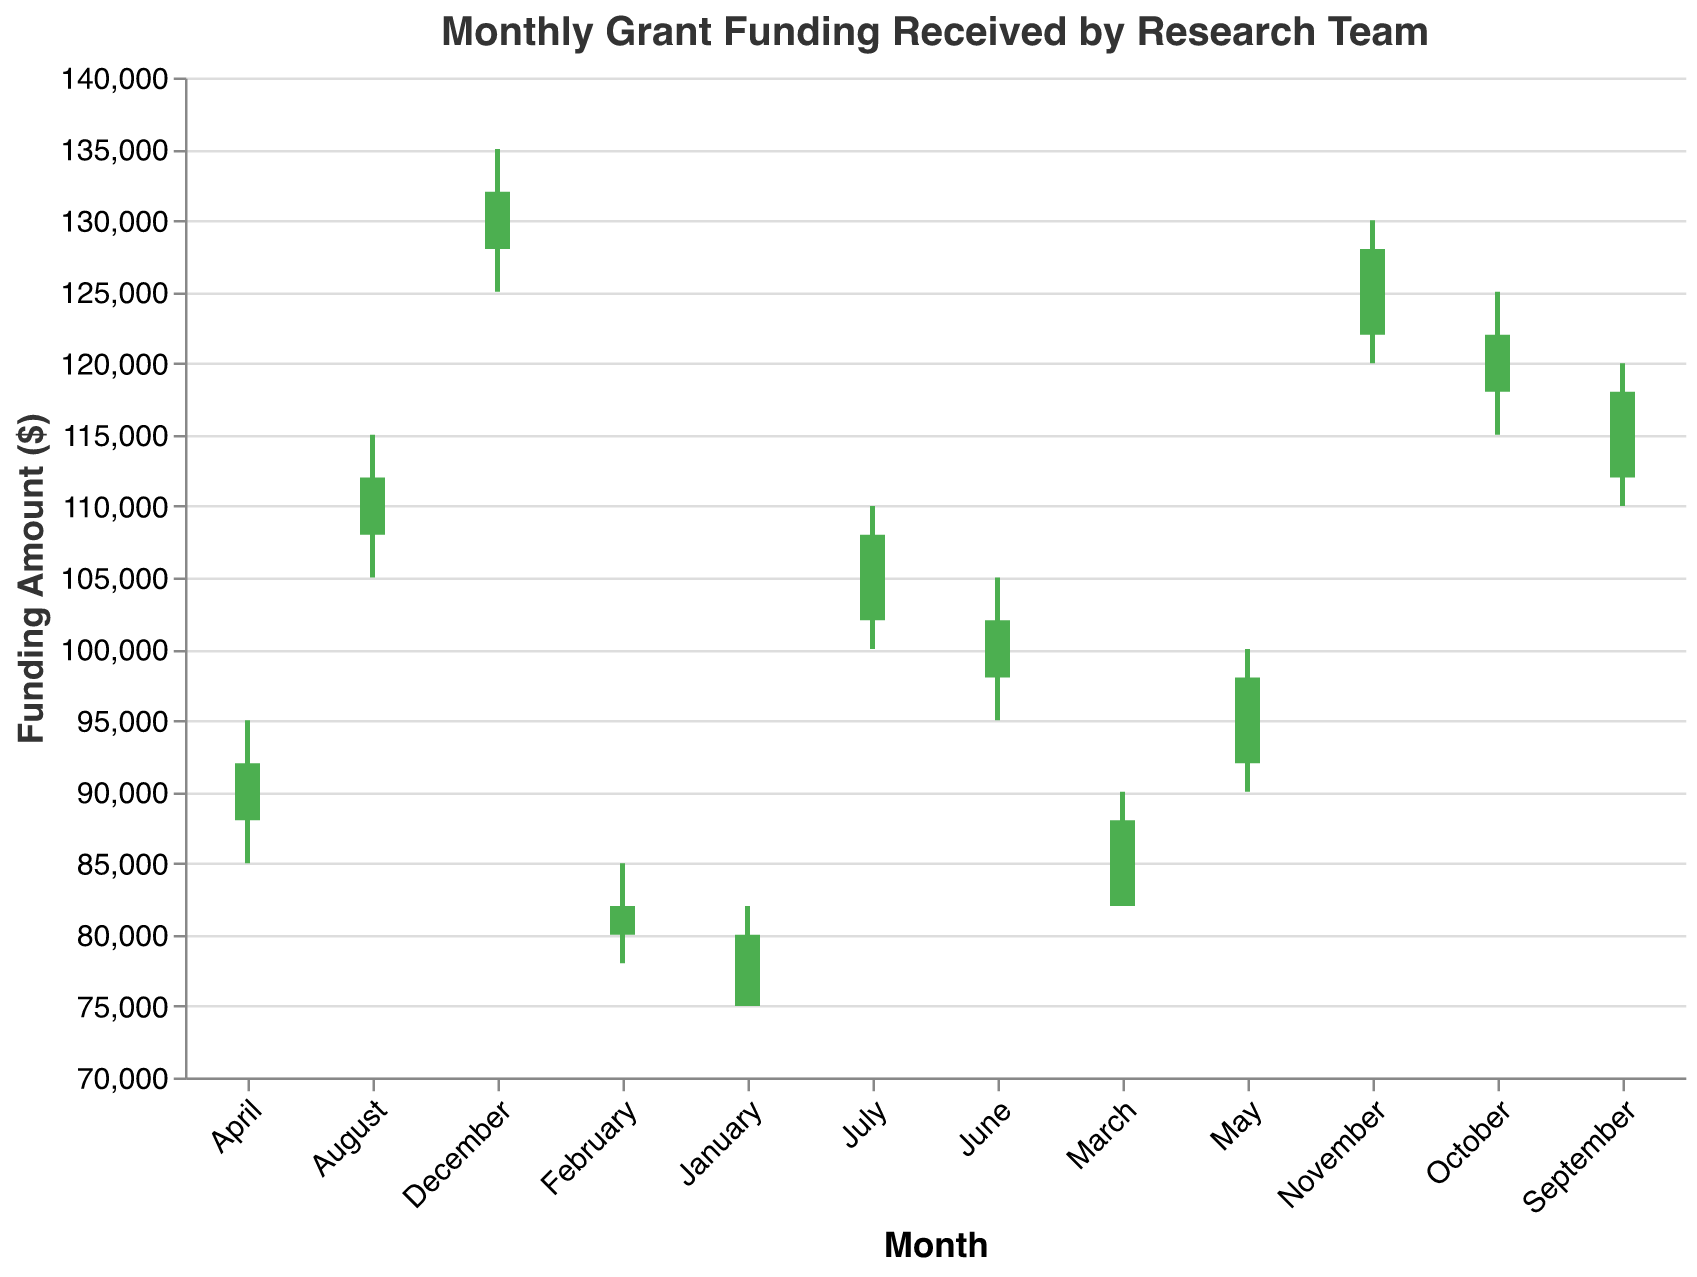what is the title of the figure? The title is displayed at the top of the figure, indicating its main subject.
Answer: Monthly Grant Funding Received by Research Team What is the final funding amount in June? The final funding amount for June can be found at the endpoint of the corresponding bar in June.
Answer: 102000 During which month did the research team receive an initial funding amount of 75000? The initial funding amount for each month is marked at the beginning of the bar along the horizontal axis, with 75000 being the initial amount for January.
Answer: January Which month had the highest peak funding? The peak funding is the maximum funding amount in the month, represented by the top point on the vertical line. The highest peak on the chart belongs to December (135000).
Answer: December What is the difference between the peak and the lowest funding amount in September? Subtract the lowest funding amount for September from the peak funding amount. Peak (120000) - Lowest (110000) = 10000.
Answer: 10000 Which months had a final funding amount greater than the initial funding amount? Look for bars where the final point is above the initial point on the vertical axis. The months are: January, February, March, April, May, June, July, August, September, October, November, December.
Answer: All months had a final funding amount greater than the initial What was the average peak funding amount over the first quarter (January, February, March)? Add the peak amounts for January, February, and March and divide by the number of months (3). (82000 + 85000 + 90000) / 3 = 85667.
Answer: 85667 During which month was the total change (final - initial) the smallest? Calculate the change for each month and find the smallest one: January (5000), February (2000), March (6000), April (4000), May (6000), June (4000), July (6000), August (4000), September (6000), October (4000), November (6000), December (4000). January has the smallest change (5000).
Answer: January By how much did the final funding amount increase from November to December? Subtract November's final amount from December's final amount. December (132000) - November (128000) = 4000.
Answer: 4000 